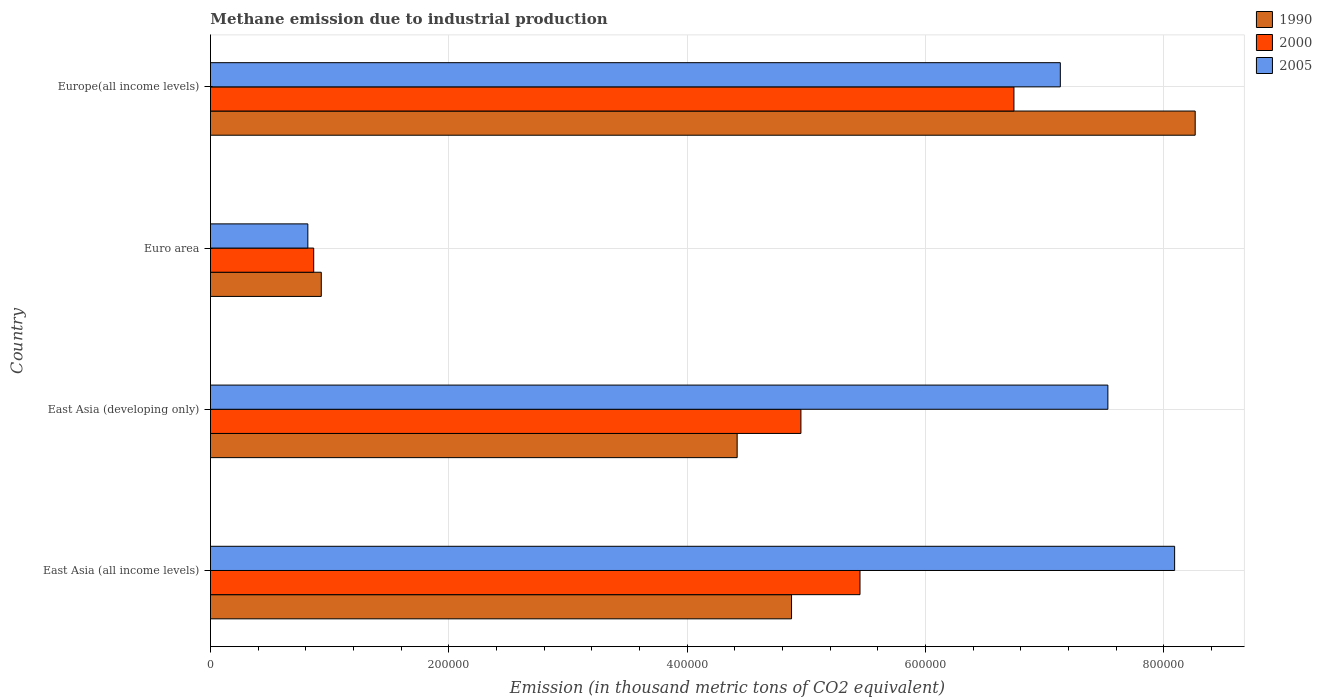How many different coloured bars are there?
Your answer should be compact. 3. How many groups of bars are there?
Offer a very short reply. 4. Are the number of bars on each tick of the Y-axis equal?
Ensure brevity in your answer.  Yes. How many bars are there on the 1st tick from the bottom?
Ensure brevity in your answer.  3. What is the label of the 4th group of bars from the top?
Provide a short and direct response. East Asia (all income levels). What is the amount of methane emitted in 2005 in Europe(all income levels)?
Give a very brief answer. 7.13e+05. Across all countries, what is the maximum amount of methane emitted in 2005?
Your answer should be compact. 8.09e+05. Across all countries, what is the minimum amount of methane emitted in 2005?
Offer a very short reply. 8.17e+04. In which country was the amount of methane emitted in 2000 maximum?
Your answer should be compact. Europe(all income levels). What is the total amount of methane emitted in 2005 in the graph?
Provide a succinct answer. 2.36e+06. What is the difference between the amount of methane emitted in 2005 in Euro area and that in Europe(all income levels)?
Offer a very short reply. -6.31e+05. What is the difference between the amount of methane emitted in 2005 in East Asia (all income levels) and the amount of methane emitted in 2000 in Europe(all income levels)?
Make the answer very short. 1.35e+05. What is the average amount of methane emitted in 2005 per country?
Ensure brevity in your answer.  5.89e+05. What is the difference between the amount of methane emitted in 2000 and amount of methane emitted in 2005 in East Asia (all income levels)?
Your answer should be compact. -2.64e+05. In how many countries, is the amount of methane emitted in 1990 greater than 320000 thousand metric tons?
Offer a very short reply. 3. What is the ratio of the amount of methane emitted in 2005 in East Asia (all income levels) to that in Euro area?
Provide a succinct answer. 9.9. Is the difference between the amount of methane emitted in 2000 in East Asia (all income levels) and Europe(all income levels) greater than the difference between the amount of methane emitted in 2005 in East Asia (all income levels) and Europe(all income levels)?
Ensure brevity in your answer.  No. What is the difference between the highest and the second highest amount of methane emitted in 2005?
Offer a very short reply. 5.60e+04. What is the difference between the highest and the lowest amount of methane emitted in 1990?
Ensure brevity in your answer.  7.33e+05. What does the 3rd bar from the top in Europe(all income levels) represents?
Keep it short and to the point. 1990. What does the 3rd bar from the bottom in East Asia (all income levels) represents?
Keep it short and to the point. 2005. How many countries are there in the graph?
Keep it short and to the point. 4. Does the graph contain any zero values?
Provide a succinct answer. No. How are the legend labels stacked?
Keep it short and to the point. Vertical. What is the title of the graph?
Provide a short and direct response. Methane emission due to industrial production. Does "2008" appear as one of the legend labels in the graph?
Your response must be concise. No. What is the label or title of the X-axis?
Offer a very short reply. Emission (in thousand metric tons of CO2 equivalent). What is the Emission (in thousand metric tons of CO2 equivalent) of 1990 in East Asia (all income levels)?
Your response must be concise. 4.88e+05. What is the Emission (in thousand metric tons of CO2 equivalent) of 2000 in East Asia (all income levels)?
Provide a succinct answer. 5.45e+05. What is the Emission (in thousand metric tons of CO2 equivalent) of 2005 in East Asia (all income levels)?
Keep it short and to the point. 8.09e+05. What is the Emission (in thousand metric tons of CO2 equivalent) of 1990 in East Asia (developing only)?
Your response must be concise. 4.42e+05. What is the Emission (in thousand metric tons of CO2 equivalent) in 2000 in East Asia (developing only)?
Your answer should be compact. 4.95e+05. What is the Emission (in thousand metric tons of CO2 equivalent) in 2005 in East Asia (developing only)?
Keep it short and to the point. 7.53e+05. What is the Emission (in thousand metric tons of CO2 equivalent) in 1990 in Euro area?
Ensure brevity in your answer.  9.30e+04. What is the Emission (in thousand metric tons of CO2 equivalent) in 2000 in Euro area?
Provide a succinct answer. 8.66e+04. What is the Emission (in thousand metric tons of CO2 equivalent) in 2005 in Euro area?
Give a very brief answer. 8.17e+04. What is the Emission (in thousand metric tons of CO2 equivalent) in 1990 in Europe(all income levels)?
Your answer should be compact. 8.26e+05. What is the Emission (in thousand metric tons of CO2 equivalent) in 2000 in Europe(all income levels)?
Make the answer very short. 6.74e+05. What is the Emission (in thousand metric tons of CO2 equivalent) of 2005 in Europe(all income levels)?
Provide a short and direct response. 7.13e+05. Across all countries, what is the maximum Emission (in thousand metric tons of CO2 equivalent) in 1990?
Give a very brief answer. 8.26e+05. Across all countries, what is the maximum Emission (in thousand metric tons of CO2 equivalent) of 2000?
Provide a succinct answer. 6.74e+05. Across all countries, what is the maximum Emission (in thousand metric tons of CO2 equivalent) in 2005?
Ensure brevity in your answer.  8.09e+05. Across all countries, what is the minimum Emission (in thousand metric tons of CO2 equivalent) in 1990?
Give a very brief answer. 9.30e+04. Across all countries, what is the minimum Emission (in thousand metric tons of CO2 equivalent) in 2000?
Ensure brevity in your answer.  8.66e+04. Across all countries, what is the minimum Emission (in thousand metric tons of CO2 equivalent) of 2005?
Provide a short and direct response. 8.17e+04. What is the total Emission (in thousand metric tons of CO2 equivalent) of 1990 in the graph?
Provide a succinct answer. 1.85e+06. What is the total Emission (in thousand metric tons of CO2 equivalent) of 2000 in the graph?
Provide a succinct answer. 1.80e+06. What is the total Emission (in thousand metric tons of CO2 equivalent) in 2005 in the graph?
Ensure brevity in your answer.  2.36e+06. What is the difference between the Emission (in thousand metric tons of CO2 equivalent) in 1990 in East Asia (all income levels) and that in East Asia (developing only)?
Give a very brief answer. 4.56e+04. What is the difference between the Emission (in thousand metric tons of CO2 equivalent) in 2000 in East Asia (all income levels) and that in East Asia (developing only)?
Offer a very short reply. 4.96e+04. What is the difference between the Emission (in thousand metric tons of CO2 equivalent) of 2005 in East Asia (all income levels) and that in East Asia (developing only)?
Your answer should be compact. 5.60e+04. What is the difference between the Emission (in thousand metric tons of CO2 equivalent) in 1990 in East Asia (all income levels) and that in Euro area?
Keep it short and to the point. 3.95e+05. What is the difference between the Emission (in thousand metric tons of CO2 equivalent) of 2000 in East Asia (all income levels) and that in Euro area?
Offer a very short reply. 4.58e+05. What is the difference between the Emission (in thousand metric tons of CO2 equivalent) of 2005 in East Asia (all income levels) and that in Euro area?
Your response must be concise. 7.27e+05. What is the difference between the Emission (in thousand metric tons of CO2 equivalent) of 1990 in East Asia (all income levels) and that in Europe(all income levels)?
Your answer should be compact. -3.39e+05. What is the difference between the Emission (in thousand metric tons of CO2 equivalent) in 2000 in East Asia (all income levels) and that in Europe(all income levels)?
Give a very brief answer. -1.29e+05. What is the difference between the Emission (in thousand metric tons of CO2 equivalent) of 2005 in East Asia (all income levels) and that in Europe(all income levels)?
Make the answer very short. 9.59e+04. What is the difference between the Emission (in thousand metric tons of CO2 equivalent) of 1990 in East Asia (developing only) and that in Euro area?
Ensure brevity in your answer.  3.49e+05. What is the difference between the Emission (in thousand metric tons of CO2 equivalent) in 2000 in East Asia (developing only) and that in Euro area?
Your answer should be very brief. 4.09e+05. What is the difference between the Emission (in thousand metric tons of CO2 equivalent) of 2005 in East Asia (developing only) and that in Euro area?
Provide a succinct answer. 6.71e+05. What is the difference between the Emission (in thousand metric tons of CO2 equivalent) in 1990 in East Asia (developing only) and that in Europe(all income levels)?
Make the answer very short. -3.84e+05. What is the difference between the Emission (in thousand metric tons of CO2 equivalent) in 2000 in East Asia (developing only) and that in Europe(all income levels)?
Keep it short and to the point. -1.79e+05. What is the difference between the Emission (in thousand metric tons of CO2 equivalent) in 2005 in East Asia (developing only) and that in Europe(all income levels)?
Provide a short and direct response. 3.99e+04. What is the difference between the Emission (in thousand metric tons of CO2 equivalent) in 1990 in Euro area and that in Europe(all income levels)?
Give a very brief answer. -7.33e+05. What is the difference between the Emission (in thousand metric tons of CO2 equivalent) of 2000 in Euro area and that in Europe(all income levels)?
Give a very brief answer. -5.88e+05. What is the difference between the Emission (in thousand metric tons of CO2 equivalent) of 2005 in Euro area and that in Europe(all income levels)?
Offer a terse response. -6.31e+05. What is the difference between the Emission (in thousand metric tons of CO2 equivalent) in 1990 in East Asia (all income levels) and the Emission (in thousand metric tons of CO2 equivalent) in 2000 in East Asia (developing only)?
Offer a very short reply. -7879.1. What is the difference between the Emission (in thousand metric tons of CO2 equivalent) in 1990 in East Asia (all income levels) and the Emission (in thousand metric tons of CO2 equivalent) in 2005 in East Asia (developing only)?
Make the answer very short. -2.65e+05. What is the difference between the Emission (in thousand metric tons of CO2 equivalent) of 2000 in East Asia (all income levels) and the Emission (in thousand metric tons of CO2 equivalent) of 2005 in East Asia (developing only)?
Keep it short and to the point. -2.08e+05. What is the difference between the Emission (in thousand metric tons of CO2 equivalent) in 1990 in East Asia (all income levels) and the Emission (in thousand metric tons of CO2 equivalent) in 2000 in Euro area?
Keep it short and to the point. 4.01e+05. What is the difference between the Emission (in thousand metric tons of CO2 equivalent) of 1990 in East Asia (all income levels) and the Emission (in thousand metric tons of CO2 equivalent) of 2005 in Euro area?
Your answer should be compact. 4.06e+05. What is the difference between the Emission (in thousand metric tons of CO2 equivalent) of 2000 in East Asia (all income levels) and the Emission (in thousand metric tons of CO2 equivalent) of 2005 in Euro area?
Give a very brief answer. 4.63e+05. What is the difference between the Emission (in thousand metric tons of CO2 equivalent) in 1990 in East Asia (all income levels) and the Emission (in thousand metric tons of CO2 equivalent) in 2000 in Europe(all income levels)?
Your answer should be very brief. -1.87e+05. What is the difference between the Emission (in thousand metric tons of CO2 equivalent) of 1990 in East Asia (all income levels) and the Emission (in thousand metric tons of CO2 equivalent) of 2005 in Europe(all income levels)?
Provide a short and direct response. -2.26e+05. What is the difference between the Emission (in thousand metric tons of CO2 equivalent) of 2000 in East Asia (all income levels) and the Emission (in thousand metric tons of CO2 equivalent) of 2005 in Europe(all income levels)?
Your answer should be very brief. -1.68e+05. What is the difference between the Emission (in thousand metric tons of CO2 equivalent) in 1990 in East Asia (developing only) and the Emission (in thousand metric tons of CO2 equivalent) in 2000 in Euro area?
Make the answer very short. 3.55e+05. What is the difference between the Emission (in thousand metric tons of CO2 equivalent) in 1990 in East Asia (developing only) and the Emission (in thousand metric tons of CO2 equivalent) in 2005 in Euro area?
Offer a very short reply. 3.60e+05. What is the difference between the Emission (in thousand metric tons of CO2 equivalent) of 2000 in East Asia (developing only) and the Emission (in thousand metric tons of CO2 equivalent) of 2005 in Euro area?
Ensure brevity in your answer.  4.14e+05. What is the difference between the Emission (in thousand metric tons of CO2 equivalent) of 1990 in East Asia (developing only) and the Emission (in thousand metric tons of CO2 equivalent) of 2000 in Europe(all income levels)?
Ensure brevity in your answer.  -2.32e+05. What is the difference between the Emission (in thousand metric tons of CO2 equivalent) of 1990 in East Asia (developing only) and the Emission (in thousand metric tons of CO2 equivalent) of 2005 in Europe(all income levels)?
Provide a succinct answer. -2.71e+05. What is the difference between the Emission (in thousand metric tons of CO2 equivalent) of 2000 in East Asia (developing only) and the Emission (in thousand metric tons of CO2 equivalent) of 2005 in Europe(all income levels)?
Your answer should be very brief. -2.18e+05. What is the difference between the Emission (in thousand metric tons of CO2 equivalent) in 1990 in Euro area and the Emission (in thousand metric tons of CO2 equivalent) in 2000 in Europe(all income levels)?
Offer a very short reply. -5.81e+05. What is the difference between the Emission (in thousand metric tons of CO2 equivalent) in 1990 in Euro area and the Emission (in thousand metric tons of CO2 equivalent) in 2005 in Europe(all income levels)?
Give a very brief answer. -6.20e+05. What is the difference between the Emission (in thousand metric tons of CO2 equivalent) in 2000 in Euro area and the Emission (in thousand metric tons of CO2 equivalent) in 2005 in Europe(all income levels)?
Give a very brief answer. -6.26e+05. What is the average Emission (in thousand metric tons of CO2 equivalent) in 1990 per country?
Your answer should be very brief. 4.62e+05. What is the average Emission (in thousand metric tons of CO2 equivalent) of 2000 per country?
Provide a short and direct response. 4.50e+05. What is the average Emission (in thousand metric tons of CO2 equivalent) of 2005 per country?
Your response must be concise. 5.89e+05. What is the difference between the Emission (in thousand metric tons of CO2 equivalent) of 1990 and Emission (in thousand metric tons of CO2 equivalent) of 2000 in East Asia (all income levels)?
Make the answer very short. -5.74e+04. What is the difference between the Emission (in thousand metric tons of CO2 equivalent) of 1990 and Emission (in thousand metric tons of CO2 equivalent) of 2005 in East Asia (all income levels)?
Offer a very short reply. -3.21e+05. What is the difference between the Emission (in thousand metric tons of CO2 equivalent) of 2000 and Emission (in thousand metric tons of CO2 equivalent) of 2005 in East Asia (all income levels)?
Make the answer very short. -2.64e+05. What is the difference between the Emission (in thousand metric tons of CO2 equivalent) of 1990 and Emission (in thousand metric tons of CO2 equivalent) of 2000 in East Asia (developing only)?
Offer a very short reply. -5.35e+04. What is the difference between the Emission (in thousand metric tons of CO2 equivalent) in 1990 and Emission (in thousand metric tons of CO2 equivalent) in 2005 in East Asia (developing only)?
Your response must be concise. -3.11e+05. What is the difference between the Emission (in thousand metric tons of CO2 equivalent) in 2000 and Emission (in thousand metric tons of CO2 equivalent) in 2005 in East Asia (developing only)?
Give a very brief answer. -2.58e+05. What is the difference between the Emission (in thousand metric tons of CO2 equivalent) of 1990 and Emission (in thousand metric tons of CO2 equivalent) of 2000 in Euro area?
Offer a very short reply. 6366.1. What is the difference between the Emission (in thousand metric tons of CO2 equivalent) of 1990 and Emission (in thousand metric tons of CO2 equivalent) of 2005 in Euro area?
Your answer should be compact. 1.13e+04. What is the difference between the Emission (in thousand metric tons of CO2 equivalent) of 2000 and Emission (in thousand metric tons of CO2 equivalent) of 2005 in Euro area?
Make the answer very short. 4908.4. What is the difference between the Emission (in thousand metric tons of CO2 equivalent) in 1990 and Emission (in thousand metric tons of CO2 equivalent) in 2000 in Europe(all income levels)?
Your answer should be very brief. 1.52e+05. What is the difference between the Emission (in thousand metric tons of CO2 equivalent) of 1990 and Emission (in thousand metric tons of CO2 equivalent) of 2005 in Europe(all income levels)?
Offer a very short reply. 1.13e+05. What is the difference between the Emission (in thousand metric tons of CO2 equivalent) in 2000 and Emission (in thousand metric tons of CO2 equivalent) in 2005 in Europe(all income levels)?
Provide a short and direct response. -3.89e+04. What is the ratio of the Emission (in thousand metric tons of CO2 equivalent) in 1990 in East Asia (all income levels) to that in East Asia (developing only)?
Offer a very short reply. 1.1. What is the ratio of the Emission (in thousand metric tons of CO2 equivalent) in 2005 in East Asia (all income levels) to that in East Asia (developing only)?
Keep it short and to the point. 1.07. What is the ratio of the Emission (in thousand metric tons of CO2 equivalent) in 1990 in East Asia (all income levels) to that in Euro area?
Ensure brevity in your answer.  5.24. What is the ratio of the Emission (in thousand metric tons of CO2 equivalent) of 2000 in East Asia (all income levels) to that in Euro area?
Provide a short and direct response. 6.29. What is the ratio of the Emission (in thousand metric tons of CO2 equivalent) in 2005 in East Asia (all income levels) to that in Euro area?
Give a very brief answer. 9.9. What is the ratio of the Emission (in thousand metric tons of CO2 equivalent) of 1990 in East Asia (all income levels) to that in Europe(all income levels)?
Offer a terse response. 0.59. What is the ratio of the Emission (in thousand metric tons of CO2 equivalent) in 2000 in East Asia (all income levels) to that in Europe(all income levels)?
Your response must be concise. 0.81. What is the ratio of the Emission (in thousand metric tons of CO2 equivalent) of 2005 in East Asia (all income levels) to that in Europe(all income levels)?
Your response must be concise. 1.13. What is the ratio of the Emission (in thousand metric tons of CO2 equivalent) in 1990 in East Asia (developing only) to that in Euro area?
Offer a terse response. 4.75. What is the ratio of the Emission (in thousand metric tons of CO2 equivalent) of 2000 in East Asia (developing only) to that in Euro area?
Offer a very short reply. 5.72. What is the ratio of the Emission (in thousand metric tons of CO2 equivalent) in 2005 in East Asia (developing only) to that in Euro area?
Provide a short and direct response. 9.22. What is the ratio of the Emission (in thousand metric tons of CO2 equivalent) in 1990 in East Asia (developing only) to that in Europe(all income levels)?
Provide a succinct answer. 0.53. What is the ratio of the Emission (in thousand metric tons of CO2 equivalent) of 2000 in East Asia (developing only) to that in Europe(all income levels)?
Keep it short and to the point. 0.73. What is the ratio of the Emission (in thousand metric tons of CO2 equivalent) of 2005 in East Asia (developing only) to that in Europe(all income levels)?
Your answer should be very brief. 1.06. What is the ratio of the Emission (in thousand metric tons of CO2 equivalent) of 1990 in Euro area to that in Europe(all income levels)?
Offer a terse response. 0.11. What is the ratio of the Emission (in thousand metric tons of CO2 equivalent) of 2000 in Euro area to that in Europe(all income levels)?
Ensure brevity in your answer.  0.13. What is the ratio of the Emission (in thousand metric tons of CO2 equivalent) in 2005 in Euro area to that in Europe(all income levels)?
Keep it short and to the point. 0.11. What is the difference between the highest and the second highest Emission (in thousand metric tons of CO2 equivalent) of 1990?
Ensure brevity in your answer.  3.39e+05. What is the difference between the highest and the second highest Emission (in thousand metric tons of CO2 equivalent) of 2000?
Offer a terse response. 1.29e+05. What is the difference between the highest and the second highest Emission (in thousand metric tons of CO2 equivalent) of 2005?
Your response must be concise. 5.60e+04. What is the difference between the highest and the lowest Emission (in thousand metric tons of CO2 equivalent) of 1990?
Offer a terse response. 7.33e+05. What is the difference between the highest and the lowest Emission (in thousand metric tons of CO2 equivalent) of 2000?
Give a very brief answer. 5.88e+05. What is the difference between the highest and the lowest Emission (in thousand metric tons of CO2 equivalent) of 2005?
Your answer should be very brief. 7.27e+05. 